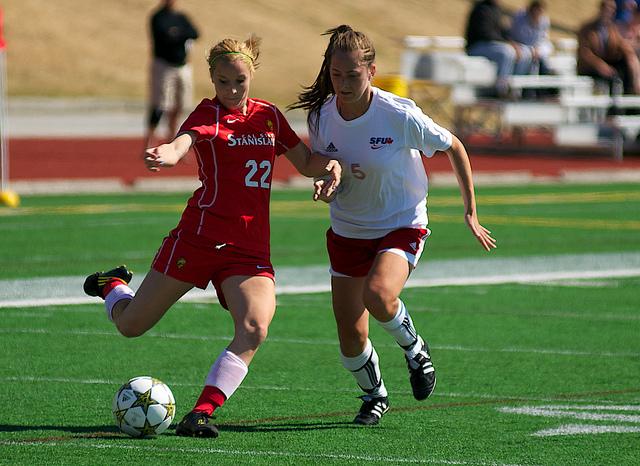Are these girls on the same team?
Answer briefly. No. Which girl has a red uniform?
Quick response, please. On left. What kind of game are the girls playing?
Write a very short answer. Soccer. Are these players of the same race?
Answer briefly. Yes. What numbers are visible?
Give a very brief answer. 22 and 5. 